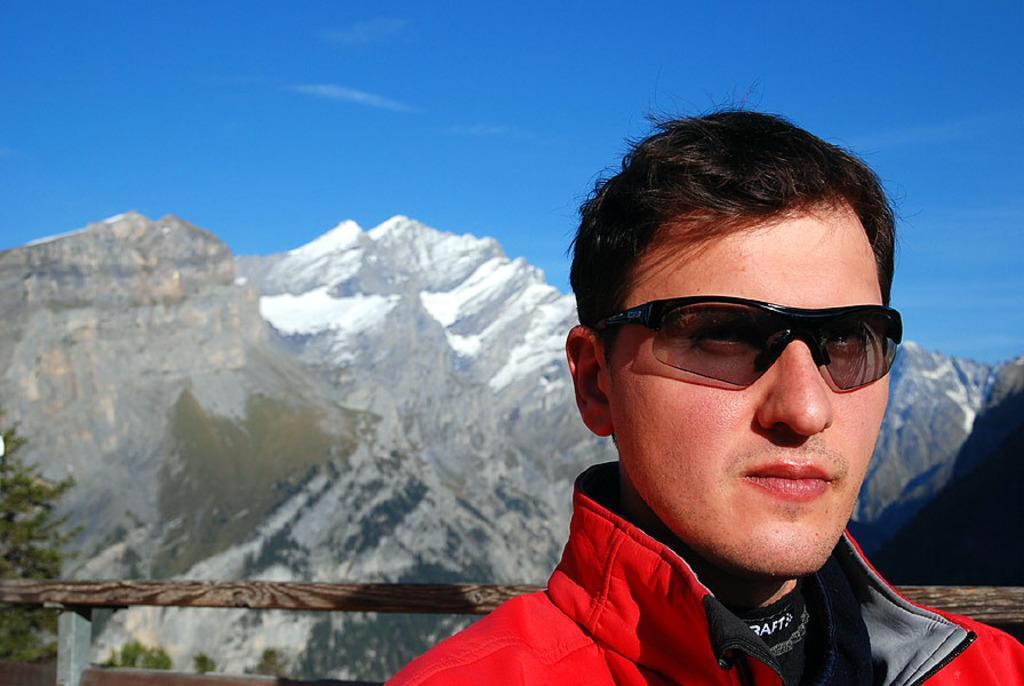Please provide a concise description of this image. In this picture, there is a man wore goggles, behind him we can see wooden fence. In the background of the image we can see trees, mountain and sky in blue color. 